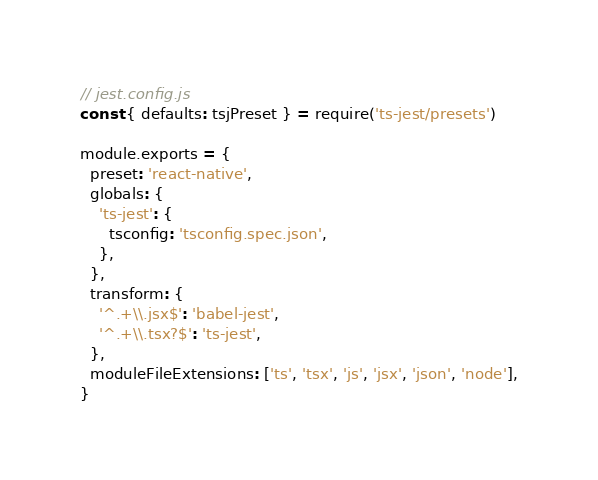<code> <loc_0><loc_0><loc_500><loc_500><_JavaScript_>// jest.config.js
const { defaults: tsjPreset } = require('ts-jest/presets')

module.exports = {
  preset: 'react-native',
  globals: {
    'ts-jest': {
      tsconfig: 'tsconfig.spec.json',
    },
  },
  transform: {
    '^.+\\.jsx$': 'babel-jest',
    '^.+\\.tsx?$': 'ts-jest',
  },
  moduleFileExtensions: ['ts', 'tsx', 'js', 'jsx', 'json', 'node'],
}
</code> 